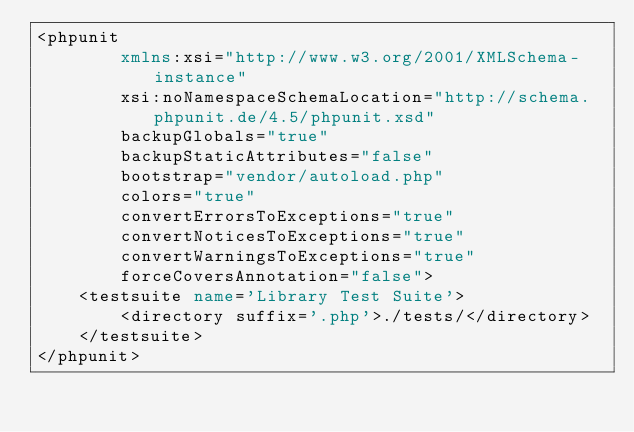<code> <loc_0><loc_0><loc_500><loc_500><_XML_><phpunit
        xmlns:xsi="http://www.w3.org/2001/XMLSchema-instance"
        xsi:noNamespaceSchemaLocation="http://schema.phpunit.de/4.5/phpunit.xsd"
        backupGlobals="true"
        backupStaticAttributes="false"
        bootstrap="vendor/autoload.php"
        colors="true"
        convertErrorsToExceptions="true"
        convertNoticesToExceptions="true"
        convertWarningsToExceptions="true"
        forceCoversAnnotation="false">
    <testsuite name='Library Test Suite'>
        <directory suffix='.php'>./tests/</directory>
    </testsuite>
</phpunit></code> 